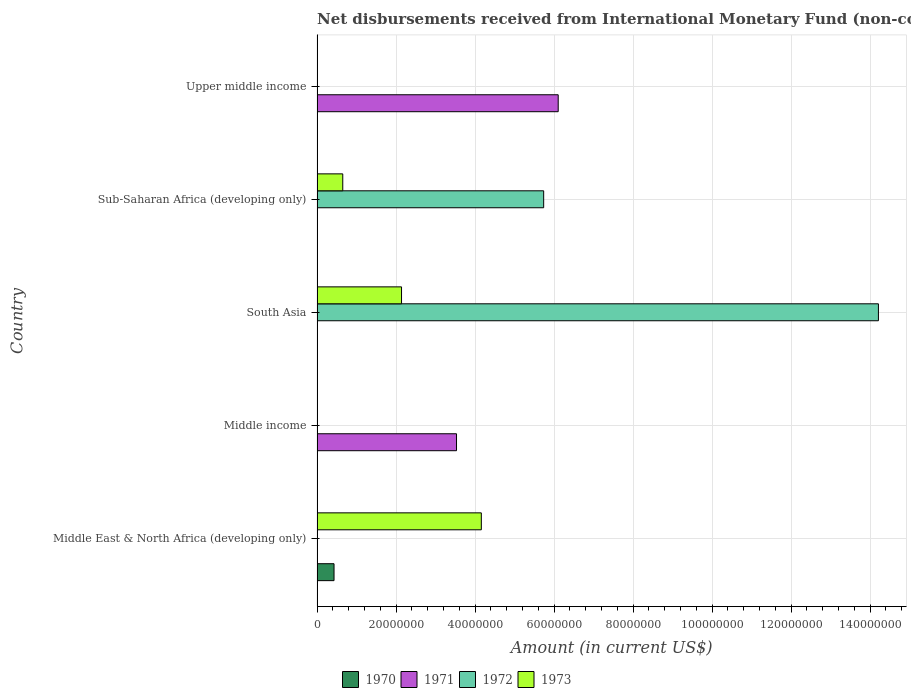How many bars are there on the 5th tick from the top?
Your answer should be very brief. 2. What is the label of the 1st group of bars from the top?
Provide a short and direct response. Upper middle income. In how many cases, is the number of bars for a given country not equal to the number of legend labels?
Your response must be concise. 5. What is the amount of disbursements received from International Monetary Fund in 1970 in Middle East & North Africa (developing only)?
Provide a short and direct response. 4.30e+06. Across all countries, what is the maximum amount of disbursements received from International Monetary Fund in 1971?
Make the answer very short. 6.11e+07. In which country was the amount of disbursements received from International Monetary Fund in 1970 maximum?
Ensure brevity in your answer.  Middle East & North Africa (developing only). What is the total amount of disbursements received from International Monetary Fund in 1970 in the graph?
Make the answer very short. 4.30e+06. What is the difference between the amount of disbursements received from International Monetary Fund in 1970 in South Asia and the amount of disbursements received from International Monetary Fund in 1973 in Middle East & North Africa (developing only)?
Offer a terse response. -4.16e+07. What is the average amount of disbursements received from International Monetary Fund in 1973 per country?
Your answer should be very brief. 1.39e+07. Is the amount of disbursements received from International Monetary Fund in 1973 in South Asia less than that in Sub-Saharan Africa (developing only)?
Provide a succinct answer. No. What is the difference between the highest and the lowest amount of disbursements received from International Monetary Fund in 1971?
Provide a short and direct response. 6.11e+07. In how many countries, is the amount of disbursements received from International Monetary Fund in 1971 greater than the average amount of disbursements received from International Monetary Fund in 1971 taken over all countries?
Provide a short and direct response. 2. How many countries are there in the graph?
Keep it short and to the point. 5. Are the values on the major ticks of X-axis written in scientific E-notation?
Offer a terse response. No. Does the graph contain grids?
Offer a terse response. Yes. How many legend labels are there?
Your response must be concise. 4. What is the title of the graph?
Make the answer very short. Net disbursements received from International Monetary Fund (non-concessional). What is the Amount (in current US$) of 1970 in Middle East & North Africa (developing only)?
Offer a very short reply. 4.30e+06. What is the Amount (in current US$) of 1971 in Middle East & North Africa (developing only)?
Your response must be concise. 0. What is the Amount (in current US$) in 1973 in Middle East & North Africa (developing only)?
Offer a very short reply. 4.16e+07. What is the Amount (in current US$) in 1970 in Middle income?
Ensure brevity in your answer.  0. What is the Amount (in current US$) in 1971 in Middle income?
Provide a succinct answer. 3.53e+07. What is the Amount (in current US$) of 1973 in Middle income?
Provide a short and direct response. 0. What is the Amount (in current US$) of 1970 in South Asia?
Provide a succinct answer. 0. What is the Amount (in current US$) of 1972 in South Asia?
Your answer should be compact. 1.42e+08. What is the Amount (in current US$) of 1973 in South Asia?
Make the answer very short. 2.14e+07. What is the Amount (in current US$) in 1971 in Sub-Saharan Africa (developing only)?
Ensure brevity in your answer.  0. What is the Amount (in current US$) in 1972 in Sub-Saharan Africa (developing only)?
Keep it short and to the point. 5.74e+07. What is the Amount (in current US$) in 1973 in Sub-Saharan Africa (developing only)?
Your answer should be compact. 6.51e+06. What is the Amount (in current US$) in 1971 in Upper middle income?
Provide a short and direct response. 6.11e+07. Across all countries, what is the maximum Amount (in current US$) of 1970?
Give a very brief answer. 4.30e+06. Across all countries, what is the maximum Amount (in current US$) in 1971?
Your response must be concise. 6.11e+07. Across all countries, what is the maximum Amount (in current US$) in 1972?
Give a very brief answer. 1.42e+08. Across all countries, what is the maximum Amount (in current US$) of 1973?
Provide a succinct answer. 4.16e+07. Across all countries, what is the minimum Amount (in current US$) of 1972?
Keep it short and to the point. 0. What is the total Amount (in current US$) of 1970 in the graph?
Your response must be concise. 4.30e+06. What is the total Amount (in current US$) of 1971 in the graph?
Keep it short and to the point. 9.64e+07. What is the total Amount (in current US$) in 1972 in the graph?
Ensure brevity in your answer.  2.00e+08. What is the total Amount (in current US$) of 1973 in the graph?
Give a very brief answer. 6.95e+07. What is the difference between the Amount (in current US$) of 1973 in Middle East & North Africa (developing only) and that in South Asia?
Provide a short and direct response. 2.02e+07. What is the difference between the Amount (in current US$) in 1973 in Middle East & North Africa (developing only) and that in Sub-Saharan Africa (developing only)?
Provide a short and direct response. 3.51e+07. What is the difference between the Amount (in current US$) in 1971 in Middle income and that in Upper middle income?
Offer a very short reply. -2.57e+07. What is the difference between the Amount (in current US$) in 1972 in South Asia and that in Sub-Saharan Africa (developing only)?
Give a very brief answer. 8.48e+07. What is the difference between the Amount (in current US$) in 1973 in South Asia and that in Sub-Saharan Africa (developing only)?
Ensure brevity in your answer.  1.49e+07. What is the difference between the Amount (in current US$) in 1970 in Middle East & North Africa (developing only) and the Amount (in current US$) in 1971 in Middle income?
Give a very brief answer. -3.10e+07. What is the difference between the Amount (in current US$) of 1970 in Middle East & North Africa (developing only) and the Amount (in current US$) of 1972 in South Asia?
Give a very brief answer. -1.38e+08. What is the difference between the Amount (in current US$) in 1970 in Middle East & North Africa (developing only) and the Amount (in current US$) in 1973 in South Asia?
Provide a succinct answer. -1.71e+07. What is the difference between the Amount (in current US$) in 1970 in Middle East & North Africa (developing only) and the Amount (in current US$) in 1972 in Sub-Saharan Africa (developing only)?
Keep it short and to the point. -5.31e+07. What is the difference between the Amount (in current US$) in 1970 in Middle East & North Africa (developing only) and the Amount (in current US$) in 1973 in Sub-Saharan Africa (developing only)?
Keep it short and to the point. -2.21e+06. What is the difference between the Amount (in current US$) of 1970 in Middle East & North Africa (developing only) and the Amount (in current US$) of 1971 in Upper middle income?
Your answer should be compact. -5.68e+07. What is the difference between the Amount (in current US$) of 1971 in Middle income and the Amount (in current US$) of 1972 in South Asia?
Offer a very short reply. -1.07e+08. What is the difference between the Amount (in current US$) in 1971 in Middle income and the Amount (in current US$) in 1973 in South Asia?
Provide a succinct answer. 1.39e+07. What is the difference between the Amount (in current US$) in 1971 in Middle income and the Amount (in current US$) in 1972 in Sub-Saharan Africa (developing only)?
Your response must be concise. -2.21e+07. What is the difference between the Amount (in current US$) of 1971 in Middle income and the Amount (in current US$) of 1973 in Sub-Saharan Africa (developing only)?
Your response must be concise. 2.88e+07. What is the difference between the Amount (in current US$) of 1972 in South Asia and the Amount (in current US$) of 1973 in Sub-Saharan Africa (developing only)?
Your response must be concise. 1.36e+08. What is the average Amount (in current US$) of 1970 per country?
Your answer should be very brief. 8.60e+05. What is the average Amount (in current US$) of 1971 per country?
Offer a very short reply. 1.93e+07. What is the average Amount (in current US$) in 1972 per country?
Your answer should be very brief. 3.99e+07. What is the average Amount (in current US$) of 1973 per country?
Provide a succinct answer. 1.39e+07. What is the difference between the Amount (in current US$) of 1970 and Amount (in current US$) of 1973 in Middle East & North Africa (developing only)?
Your response must be concise. -3.73e+07. What is the difference between the Amount (in current US$) in 1972 and Amount (in current US$) in 1973 in South Asia?
Offer a terse response. 1.21e+08. What is the difference between the Amount (in current US$) of 1972 and Amount (in current US$) of 1973 in Sub-Saharan Africa (developing only)?
Make the answer very short. 5.09e+07. What is the ratio of the Amount (in current US$) in 1973 in Middle East & North Africa (developing only) to that in South Asia?
Ensure brevity in your answer.  1.94. What is the ratio of the Amount (in current US$) of 1973 in Middle East & North Africa (developing only) to that in Sub-Saharan Africa (developing only)?
Make the answer very short. 6.39. What is the ratio of the Amount (in current US$) in 1971 in Middle income to that in Upper middle income?
Your response must be concise. 0.58. What is the ratio of the Amount (in current US$) of 1972 in South Asia to that in Sub-Saharan Africa (developing only)?
Ensure brevity in your answer.  2.48. What is the ratio of the Amount (in current US$) of 1973 in South Asia to that in Sub-Saharan Africa (developing only)?
Keep it short and to the point. 3.29. What is the difference between the highest and the second highest Amount (in current US$) of 1973?
Make the answer very short. 2.02e+07. What is the difference between the highest and the lowest Amount (in current US$) in 1970?
Make the answer very short. 4.30e+06. What is the difference between the highest and the lowest Amount (in current US$) of 1971?
Provide a short and direct response. 6.11e+07. What is the difference between the highest and the lowest Amount (in current US$) in 1972?
Keep it short and to the point. 1.42e+08. What is the difference between the highest and the lowest Amount (in current US$) of 1973?
Ensure brevity in your answer.  4.16e+07. 